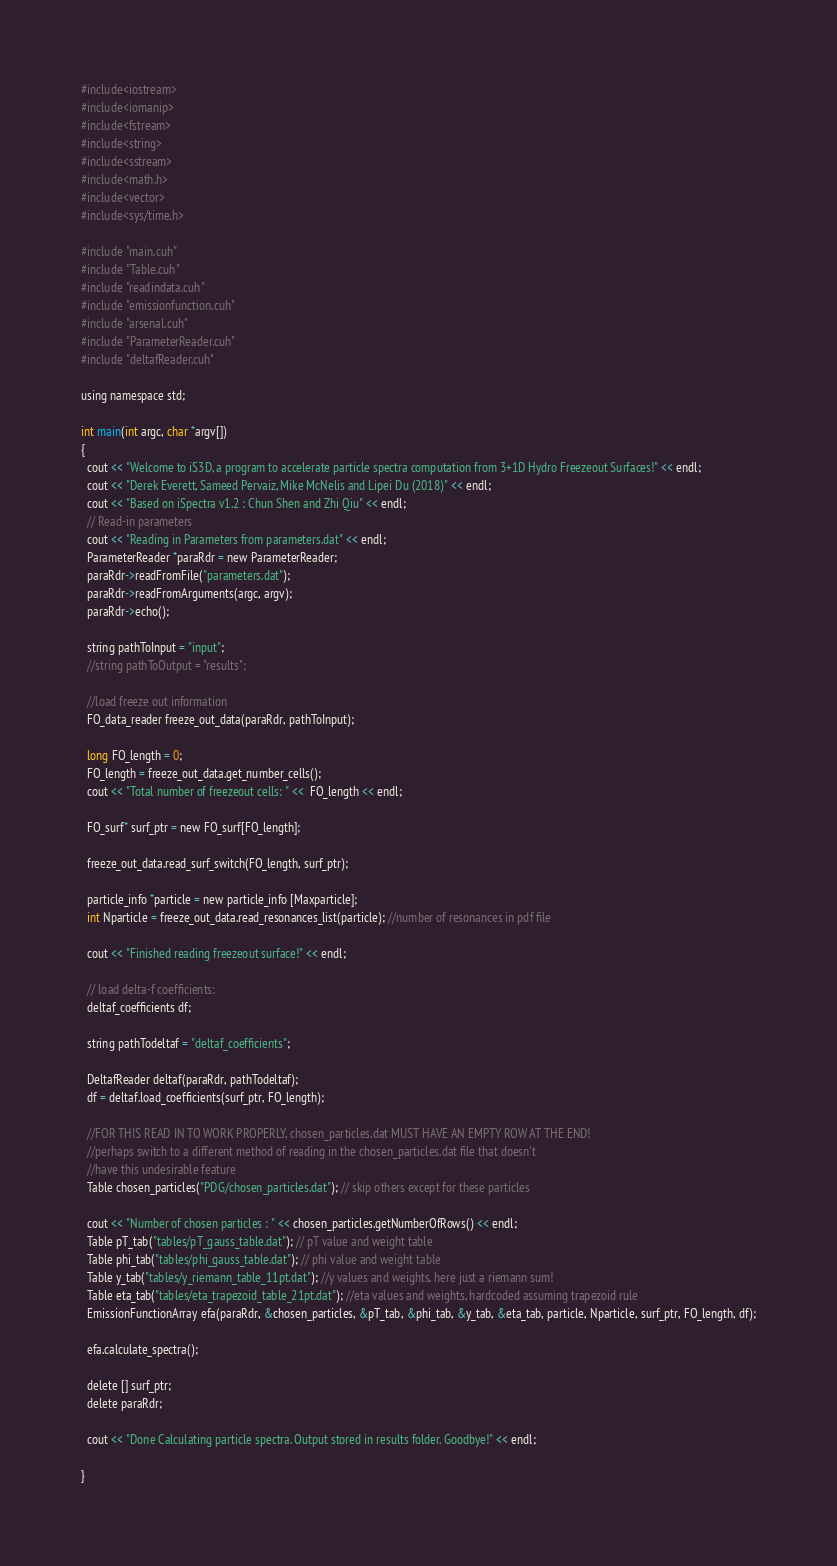Convert code to text. <code><loc_0><loc_0><loc_500><loc_500><_Cuda_>
#include<iostream>
#include<iomanip>
#include<fstream>
#include<string>
#include<sstream>
#include<math.h>
#include<vector>
#include<sys/time.h>

#include "main.cuh"
#include "Table.cuh"
#include "readindata.cuh"
#include "emissionfunction.cuh"
#include "arsenal.cuh"
#include "ParameterReader.cuh"
#include "deltafReader.cuh"

using namespace std;

int main(int argc, char *argv[])
{
  cout << "Welcome to iS3D, a program to accelerate particle spectra computation from 3+1D Hydro Freezeout Surfaces!" << endl;
  cout << "Derek Everett, Sameed Pervaiz, Mike McNelis and Lipei Du (2018)" << endl;
  cout << "Based on iSpectra v1.2 : Chun Shen and Zhi Qiu" << endl;
  // Read-in parameters
  cout << "Reading in Parameters from parameters.dat" << endl;
  ParameterReader *paraRdr = new ParameterReader;
  paraRdr->readFromFile("parameters.dat");
  paraRdr->readFromArguments(argc, argv);
  paraRdr->echo();

  string pathToInput = "input";
  //string pathToOutput = "results";

  //load freeze out information
  FO_data_reader freeze_out_data(paraRdr, pathToInput);

  long FO_length = 0;
  FO_length = freeze_out_data.get_number_cells();
  cout << "Total number of freezeout cells: " <<  FO_length << endl;

  FO_surf* surf_ptr = new FO_surf[FO_length];

  freeze_out_data.read_surf_switch(FO_length, surf_ptr);

  particle_info *particle = new particle_info [Maxparticle];
  int Nparticle = freeze_out_data.read_resonances_list(particle); //number of resonances in pdf file

  cout << "Finished reading freezeout surface!" << endl;

  // load delta-f coefficients:
  deltaf_coefficients df;

  string pathTodeltaf = "deltaf_coefficients";

  DeltafReader deltaf(paraRdr, pathTodeltaf);
  df = deltaf.load_coefficients(surf_ptr, FO_length);

  //FOR THIS READ IN TO WORK PROPERLY, chosen_particles.dat MUST HAVE AN EMPTY ROW AT THE END!
  //perhaps switch to a different method of reading in the chosen_particles.dat file that doesn't
  //have this undesirable feature
  Table chosen_particles("PDG/chosen_particles.dat"); // skip others except for these particles

  cout << "Number of chosen particles : " << chosen_particles.getNumberOfRows() << endl;
  Table pT_tab("tables/pT_gauss_table.dat"); // pT value and weight table
  Table phi_tab("tables/phi_gauss_table.dat"); // phi value and weight table
  Table y_tab("tables/y_riemann_table_11pt.dat"); //y values and weights, here just a riemann sum!
  Table eta_tab("tables/eta_trapezoid_table_21pt.dat"); //eta values and weights, hardcoded assuming trapezoid rule 
  EmissionFunctionArray efa(paraRdr, &chosen_particles, &pT_tab, &phi_tab, &y_tab, &eta_tab, particle, Nparticle, surf_ptr, FO_length, df);

  efa.calculate_spectra();

  delete [] surf_ptr;
  delete paraRdr;

  cout << "Done Calculating particle spectra. Output stored in results folder. Goodbye!" << endl;

}
</code> 